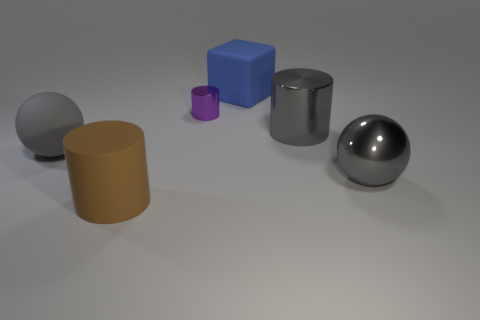Subtract all small purple shiny cylinders. How many cylinders are left? 2 Subtract all purple cylinders. How many cylinders are left? 2 Add 1 matte cylinders. How many objects exist? 7 Subtract all cubes. How many objects are left? 5 Subtract all purple cylinders. Subtract all purple spheres. How many cylinders are left? 2 Add 4 large matte spheres. How many large matte spheres are left? 5 Add 3 brown matte blocks. How many brown matte blocks exist? 3 Subtract 0 gray blocks. How many objects are left? 6 Subtract all large green matte balls. Subtract all blue things. How many objects are left? 5 